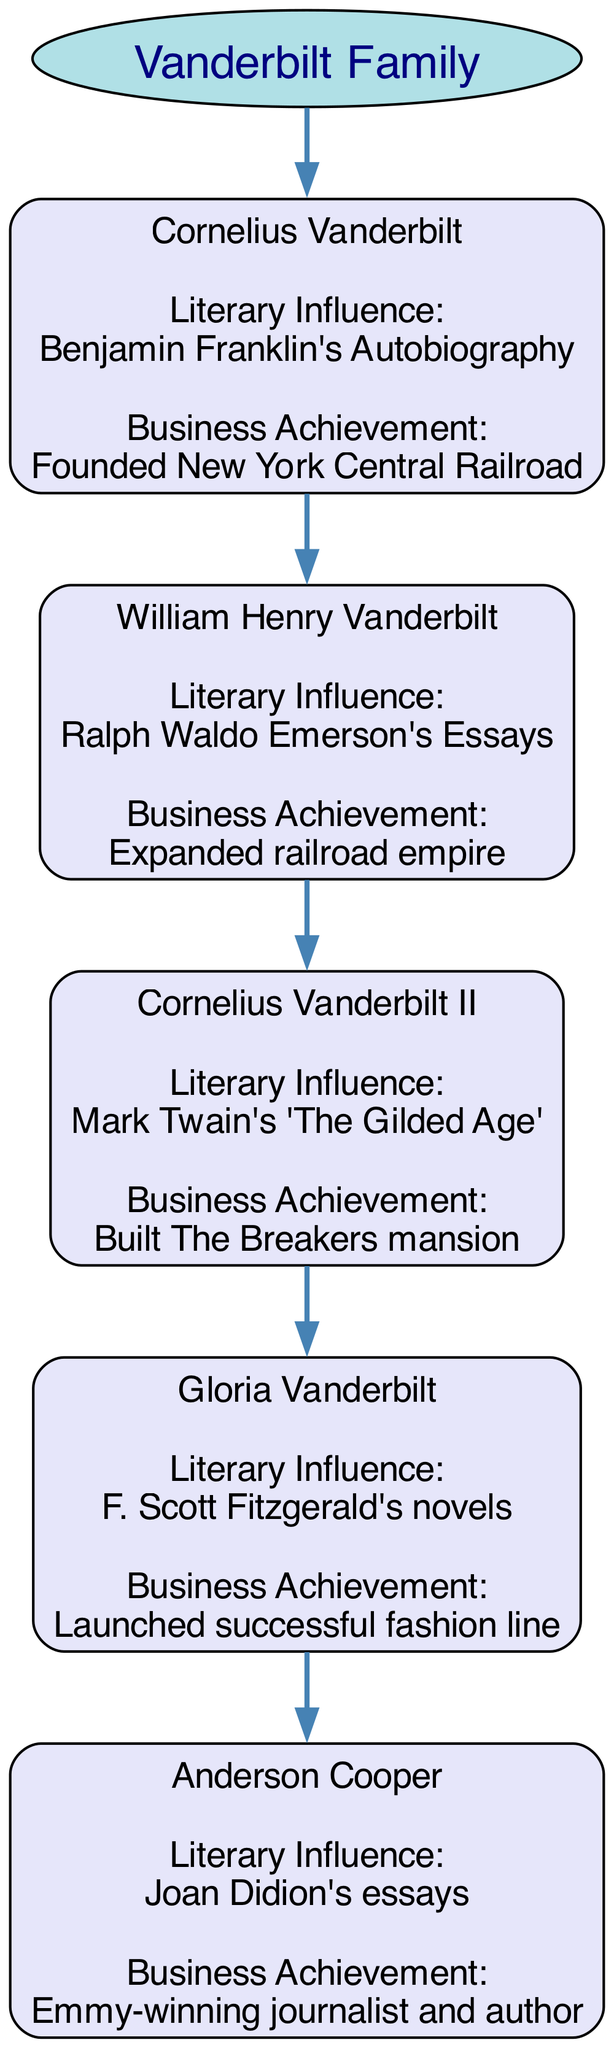What is the founding achievement of Cornelius Vanderbilt? Cornelius Vanderbilt is identified in the diagram as the founder of the New York Central Railroad, which is mentioned under his business achievement label.
Answer: Founded New York Central Railroad Who is the literary influence of Gloria Vanderbilt? The diagram specifies that Gloria Vanderbilt was influenced by F. Scott Fitzgerald's novels, which is detailed under her literary influence label.
Answer: F. Scott Fitzgerald's novels How many generations does the family tree showcase? There are a total of five generations displayed in the diagram, each represented by a unique node for each family member under the "Vanderbilt Family" root.
Answer: 5 Which family member is associated with "The Breakers" mansion? The diagram connects Cornelius Vanderbilt II to the business achievement of building The Breakers mansion, as noted in his business achievement label.
Answer: Cornelius Vanderbilt II What literary work influenced William Henry Vanderbilt? The diagram indicates that William Henry Vanderbilt was influenced by Ralph Waldo Emerson's Essays, which is clearly specified in his literary influence section.
Answer: Ralph Waldo Emerson's Essays Which member of the family is a journalist and author? The diagram specifies that Anderson Cooper is recognized as an Emmy-winning journalist and author, which is mentioned as his business achievement.
Answer: Anderson Cooper How is Anderson Cooper related to Cornelius Vanderbilt? The diagram implies that Anderson Cooper is a descendant of Cornelius Vanderbilt, as he is positioned in the generational hierarchy below him and connects back to the family lineage.
Answer: Great-grandson What color represents the nodes in the diagram? The nodes in the diagram are filled with a light lavender color (#E6E6FA), which is specified in the graph attributes for the nodes.
Answer: Light lavender What shape is used for the root node in the family tree? The root node representing the "Vanderbilt Family" is depicted in an ellipse shape, which is specified in the graph definition for the root attributes.
Answer: Ellipse 